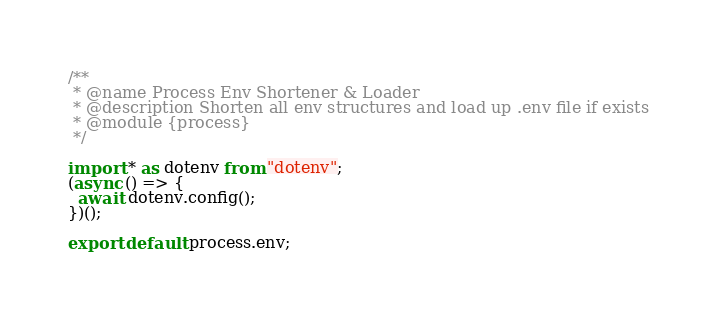<code> <loc_0><loc_0><loc_500><loc_500><_TypeScript_>/**
 * @name Process Env Shortener & Loader
 * @description Shorten all env structures and load up .env file if exists
 * @module {process}
 */

import * as dotenv from "dotenv";
(async () => {
  await dotenv.config();
})();

export default process.env;
</code> 